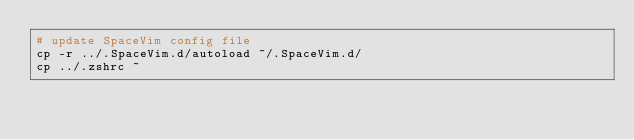<code> <loc_0><loc_0><loc_500><loc_500><_Bash_># update SpaceVim config file
cp -r ../.SpaceVim.d/autoload ~/.SpaceVim.d/
cp ../.zshrc ~

</code> 